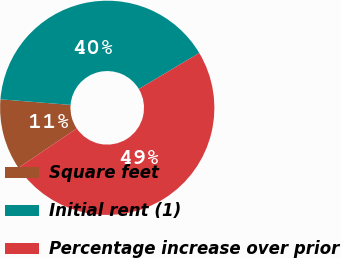Convert chart. <chart><loc_0><loc_0><loc_500><loc_500><pie_chart><fcel>Square feet<fcel>Initial rent (1)<fcel>Percentage increase over prior<nl><fcel>10.73%<fcel>40.18%<fcel>49.09%<nl></chart> 